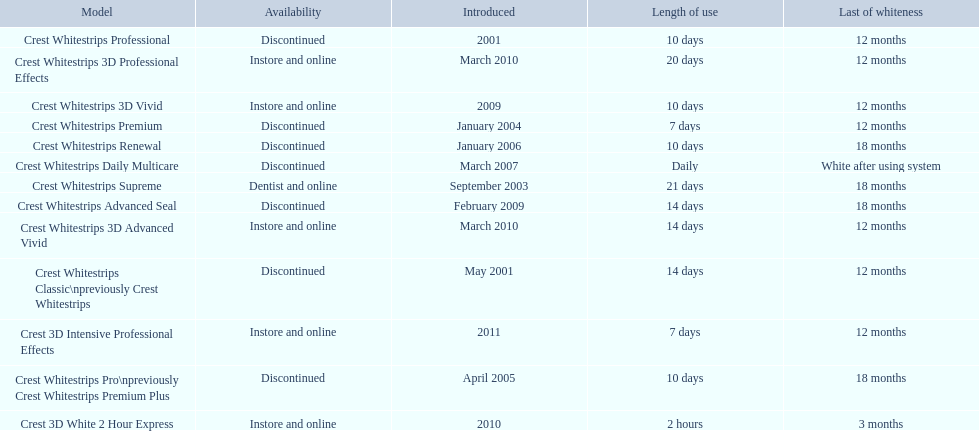Which models are still available? Crest Whitestrips Supreme, Crest Whitestrips 3D Vivid, Crest Whitestrips 3D Advanced Vivid, Crest Whitestrips 3D Professional Effects, Crest 3D White 2 Hour Express, Crest 3D Intensive Professional Effects. Of those, which were introduced prior to 2011? Crest Whitestrips Supreme, Crest Whitestrips 3D Vivid, Crest Whitestrips 3D Advanced Vivid, Crest Whitestrips 3D Professional Effects, Crest 3D White 2 Hour Express. Among those models, which ones had to be used at least 14 days? Crest Whitestrips Supreme, Crest Whitestrips 3D Advanced Vivid, Crest Whitestrips 3D Professional Effects. Which of those lasted longer than 12 months? Crest Whitestrips Supreme. 